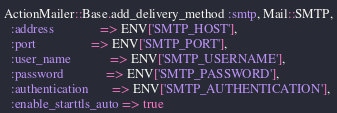<code> <loc_0><loc_0><loc_500><loc_500><_Ruby_>ActionMailer::Base.add_delivery_method :smtp, Mail::SMTP,
  :address              => ENV['SMTP_HOST'],
  :port                 => ENV['SMTP_PORT'],
  :user_name            => ENV['SMTP_USERNAME'],
  :password             => ENV['SMTP_PASSWORD'],
  :authentication       => ENV['SMTP_AUTHENTICATION'],
  :enable_starttls_auto => true

</code> 